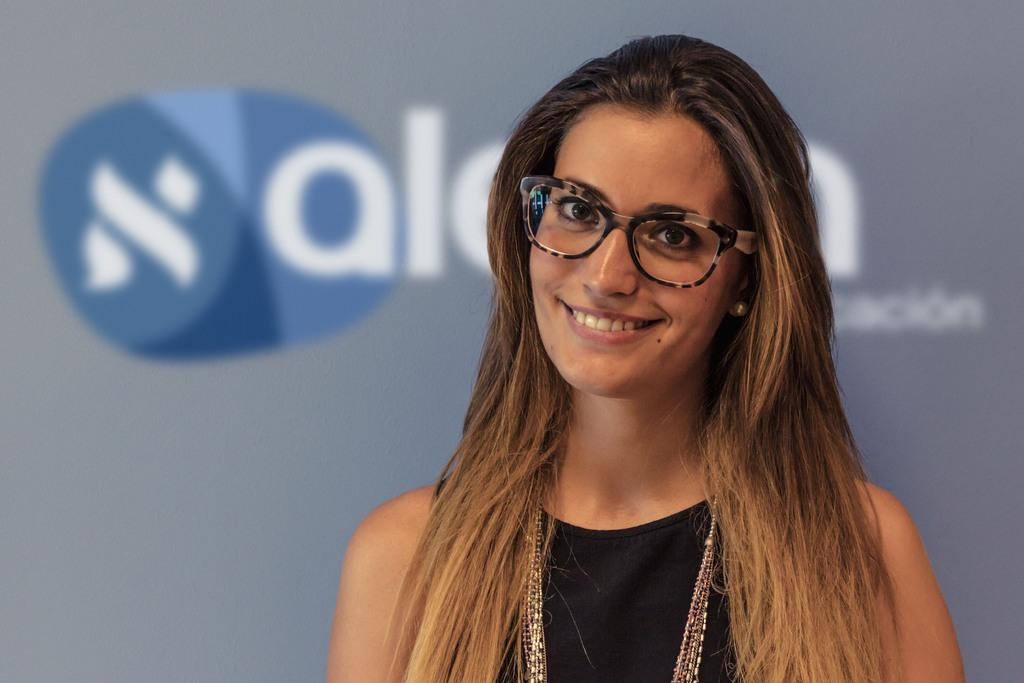Who is the main subject in the image? There is a lady in the image. Where is the lady located in the image? The lady is on the right side of the image. What can be seen in the background of the image? There is a poster in the background of the image. What type of cheese is being used to decorate the lady's hair in the image? There is no cheese present in the image, and the lady's hair is not decorated with any cheese. 